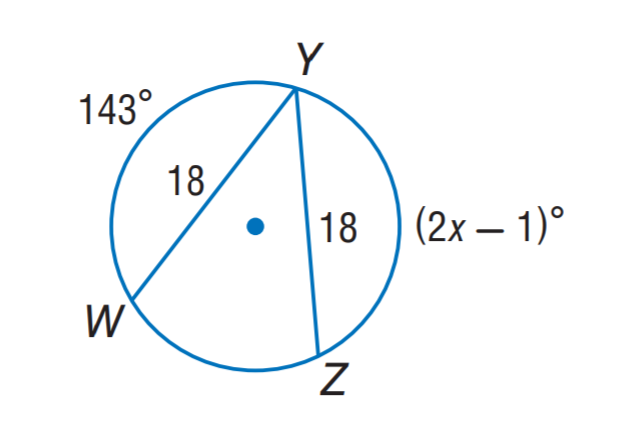Question: Find x.
Choices:
A. 72
B. 82
C. 84
D. 143
Answer with the letter. Answer: A 